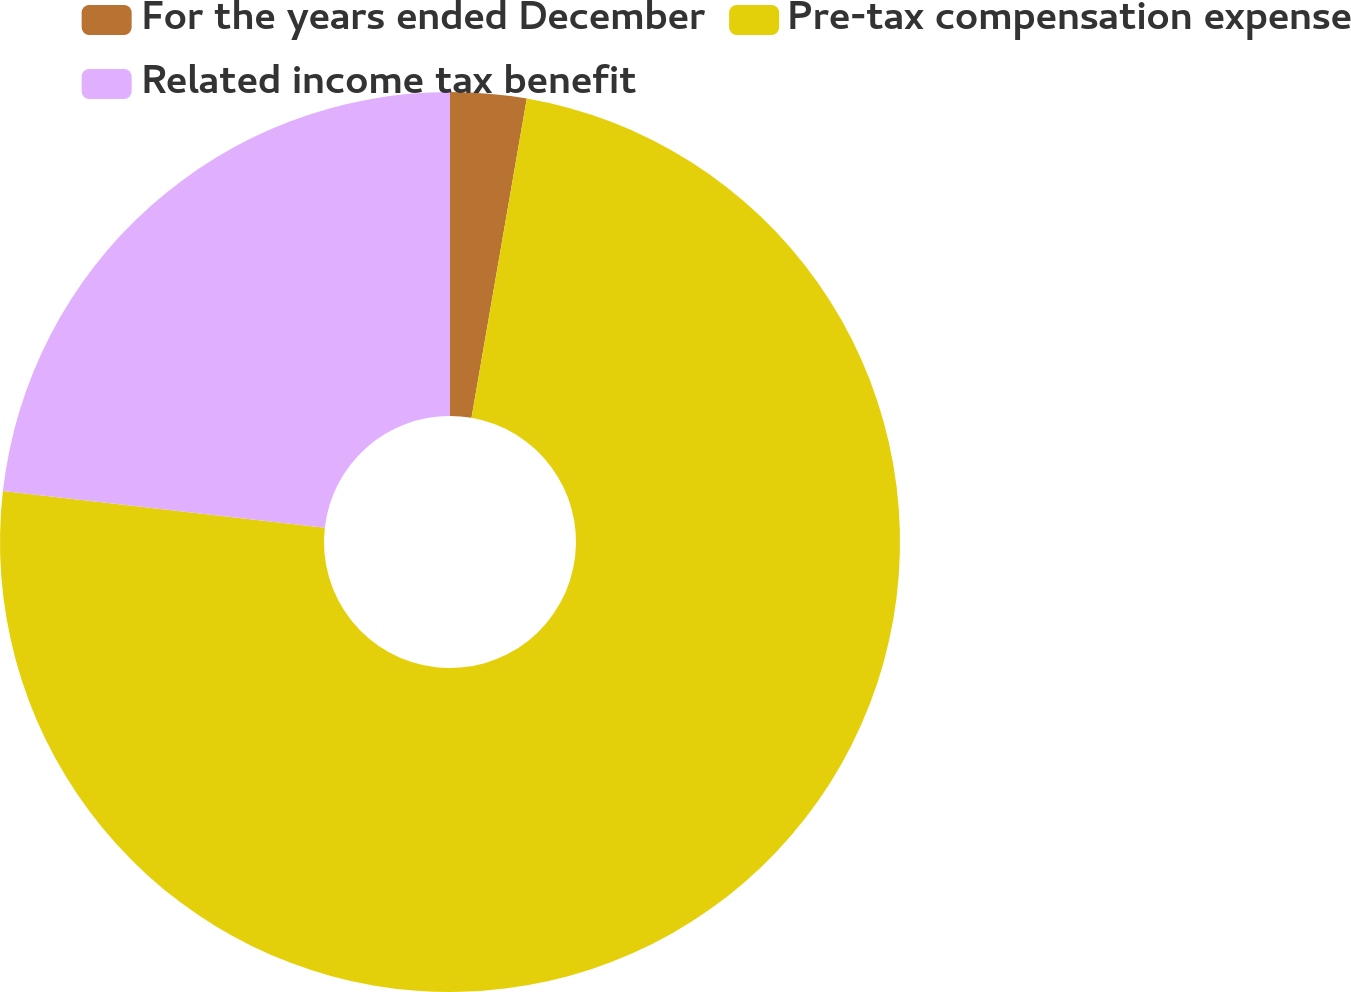<chart> <loc_0><loc_0><loc_500><loc_500><pie_chart><fcel>For the years ended December<fcel>Pre-tax compensation expense<fcel>Related income tax benefit<nl><fcel>2.73%<fcel>74.08%<fcel>23.19%<nl></chart> 